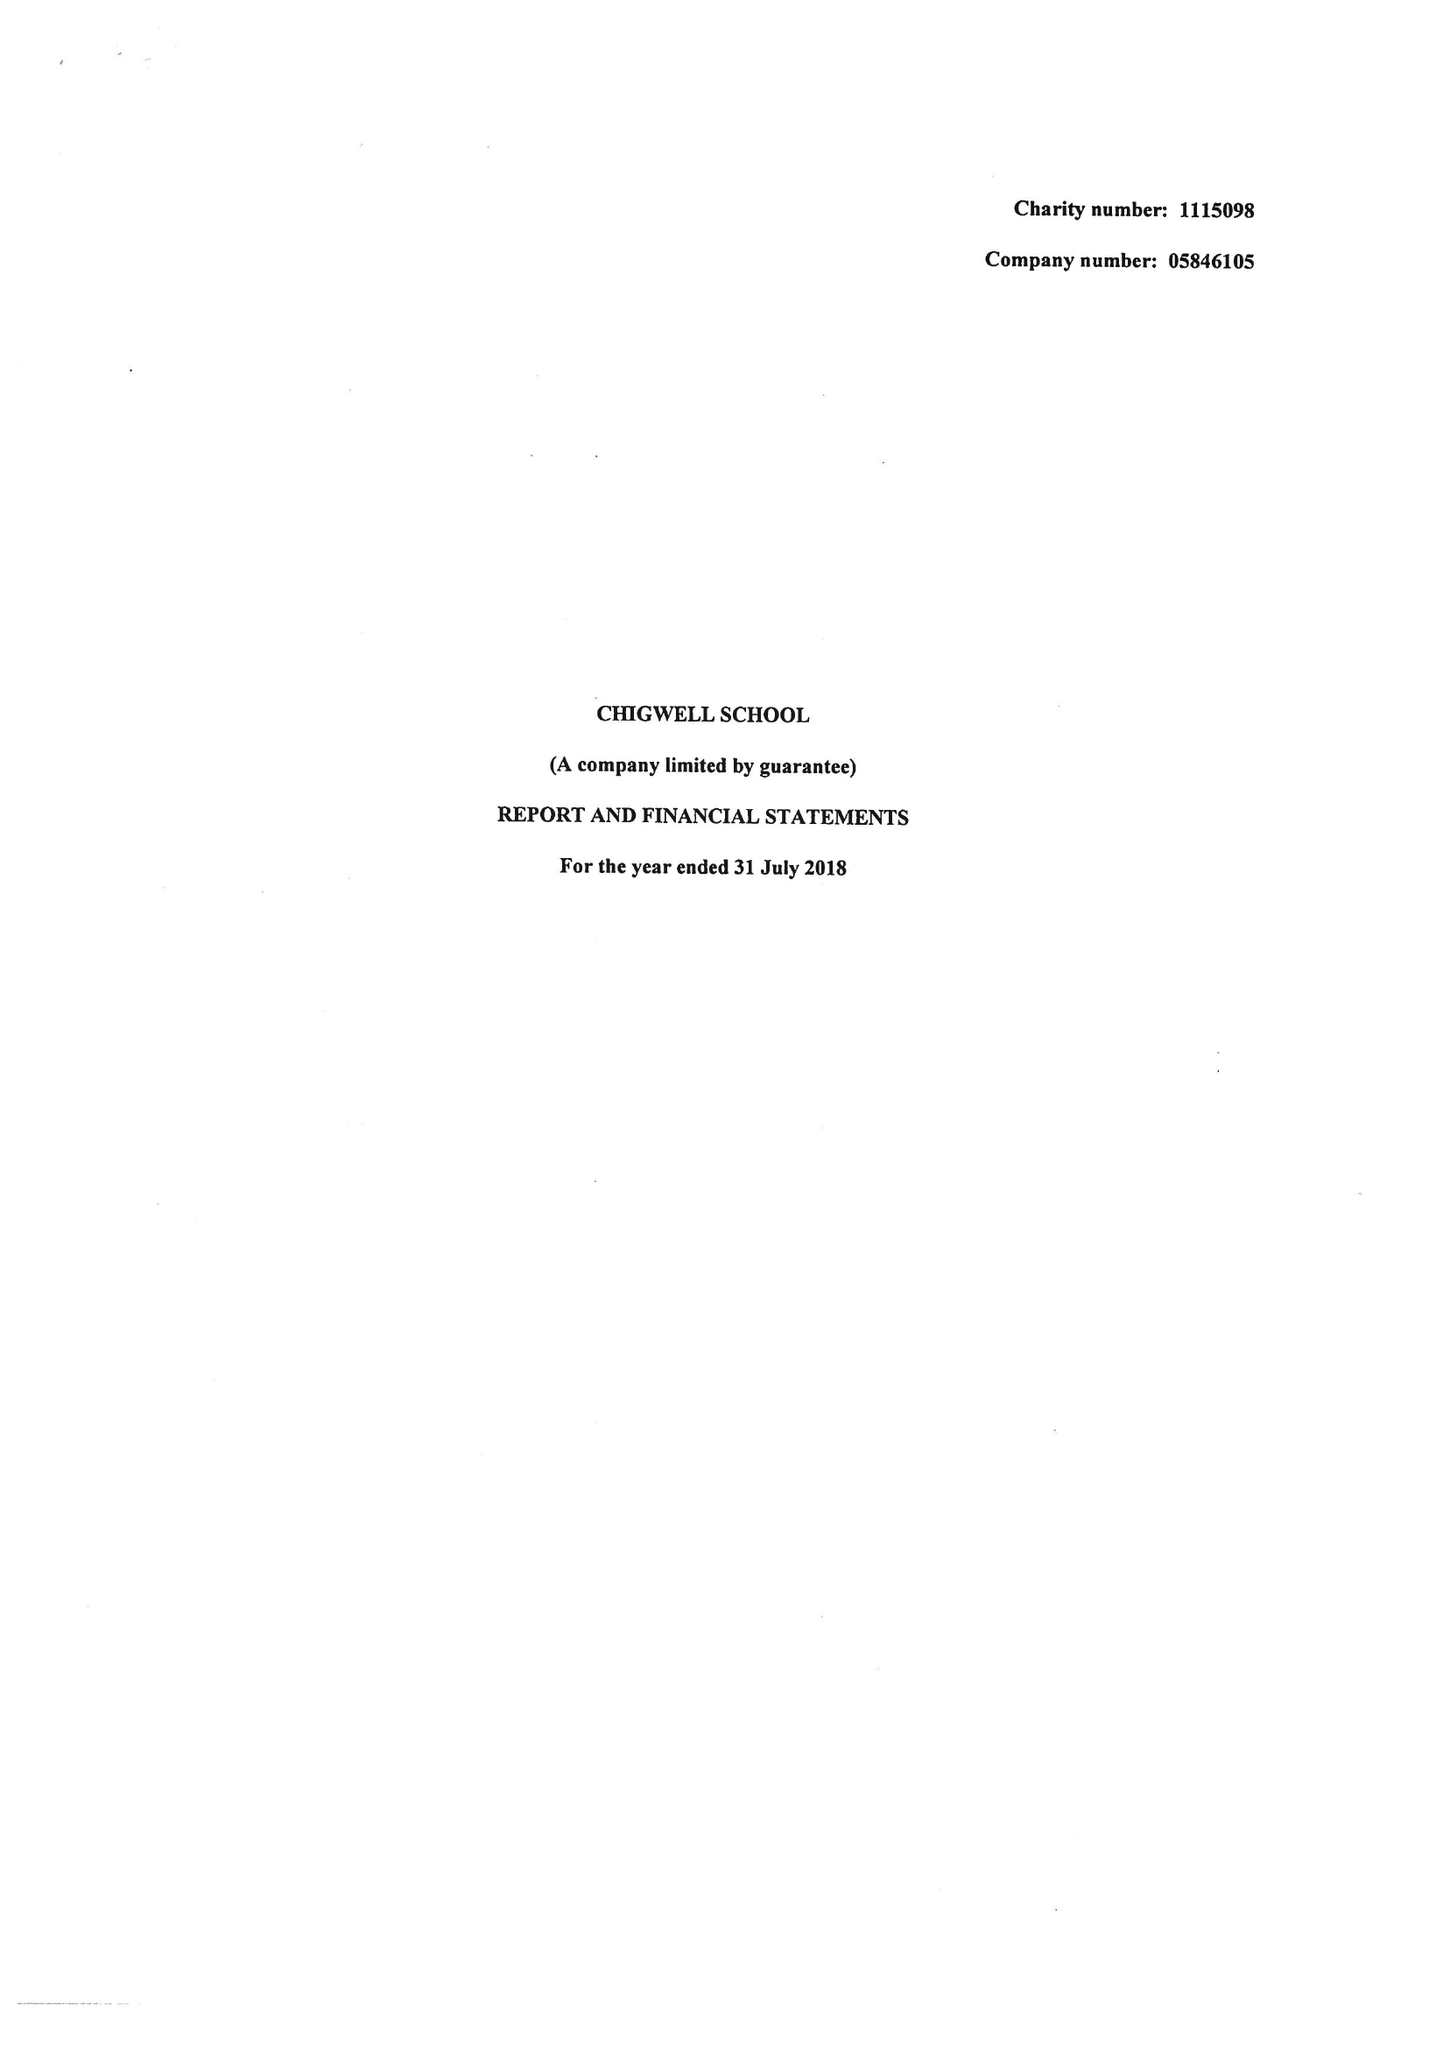What is the value for the charity_number?
Answer the question using a single word or phrase. 1115098 